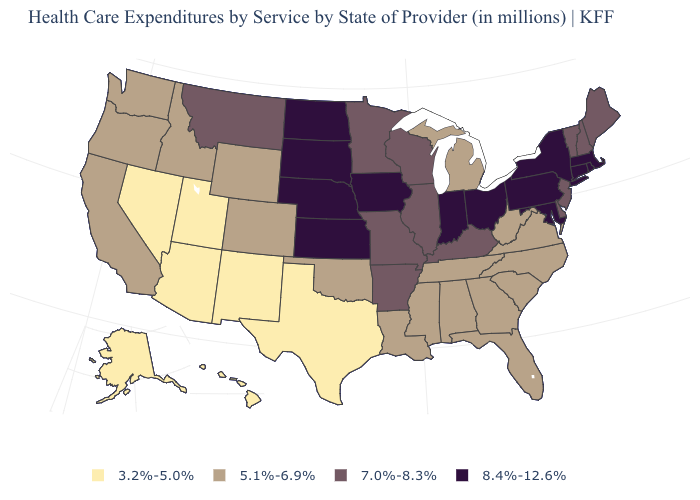Which states have the lowest value in the West?
Answer briefly. Alaska, Arizona, Hawaii, Nevada, New Mexico, Utah. Does the map have missing data?
Short answer required. No. Does South Carolina have a lower value than Hawaii?
Be succinct. No. Does the first symbol in the legend represent the smallest category?
Write a very short answer. Yes. What is the value of Louisiana?
Answer briefly. 5.1%-6.9%. What is the highest value in states that border Mississippi?
Concise answer only. 7.0%-8.3%. Name the states that have a value in the range 8.4%-12.6%?
Quick response, please. Connecticut, Indiana, Iowa, Kansas, Maryland, Massachusetts, Nebraska, New York, North Dakota, Ohio, Pennsylvania, Rhode Island, South Dakota. Does the map have missing data?
Concise answer only. No. Does the first symbol in the legend represent the smallest category?
Quick response, please. Yes. What is the value of North Dakota?
Keep it brief. 8.4%-12.6%. What is the lowest value in states that border Texas?
Give a very brief answer. 3.2%-5.0%. Which states have the lowest value in the USA?
Write a very short answer. Alaska, Arizona, Hawaii, Nevada, New Mexico, Texas, Utah. What is the lowest value in the South?
Concise answer only. 3.2%-5.0%. Name the states that have a value in the range 7.0%-8.3%?
Keep it brief. Arkansas, Delaware, Illinois, Kentucky, Maine, Minnesota, Missouri, Montana, New Hampshire, New Jersey, Vermont, Wisconsin. What is the value of Pennsylvania?
Be succinct. 8.4%-12.6%. 